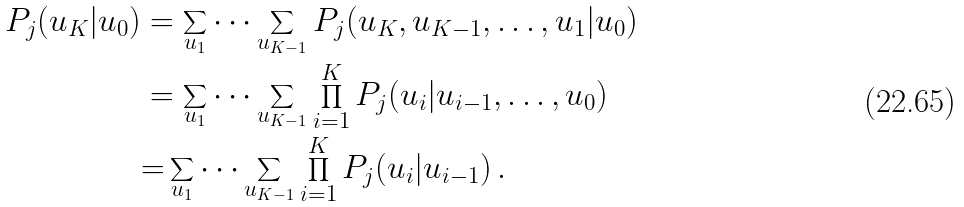<formula> <loc_0><loc_0><loc_500><loc_500>P _ { j } ( u _ { K } | u _ { 0 } ) & = \sum _ { u _ { 1 } } \dots \sum _ { u _ { K - 1 } } P _ { j } ( u _ { K } , u _ { K - 1 } , \dots , u _ { 1 } | u _ { 0 } ) \\ & = \sum _ { u _ { 1 } } \dots \sum _ { u _ { K - 1 } } \prod _ { i = 1 } ^ { K } P _ { j } ( u _ { i } | u _ { i - 1 } , \dots , u _ { 0 } ) \\ & { = } \sum _ { u _ { 1 } } \dots \sum _ { u _ { K - 1 } } \prod _ { i = 1 } ^ { K } P _ { j } ( u _ { i } | u _ { i - 1 } ) \, .</formula> 